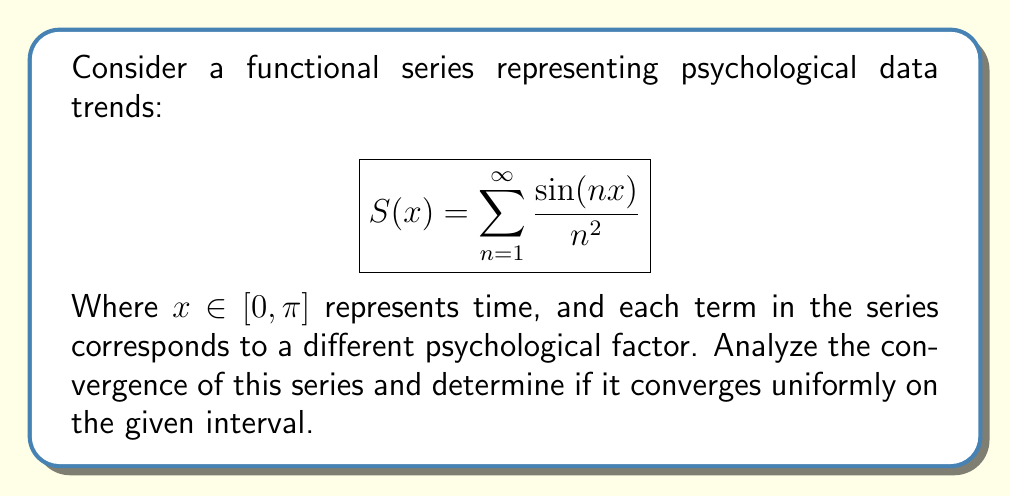Can you answer this question? To analyze the convergence of this functional series, we'll follow these steps:

1. Pointwise convergence:
First, we need to check if the series converges pointwise for all $x \in [0, \pi]$. We can use the Weierstrass M-test for this.

Let $M_n = \frac{1}{n^2}$. We know that $|\sin(nx)| \leq 1$ for all $x$ and $n$. Therefore:

$$\left|\frac{\sin(nx)}{n^2}\right| \leq \frac{1}{n^2} = M_n$$

The series $\sum_{n=1}^{\infty} M_n = \sum_{n=1}^{\infty} \frac{1}{n^2}$ is the p-series with $p=2$, which converges (it's actually $\frac{\pi^2}{6}$).

By the Weierstrass M-test, since $\sum_{n=1}^{\infty} M_n$ converges, our original series converges absolutely and uniformly on $[0, \pi]$.

2. Uniform convergence:
We've already shown uniform convergence using the Weierstrass M-test. However, we can also demonstrate it using the Cauchy criterion for uniform convergence.

For any $\epsilon > 0$, we need to find an $N$ such that for all $m > n \geq N$ and all $x \in [0, \pi]$:

$$\left|\sum_{k=n+1}^m \frac{\sin(kx)}{k^2}\right| < \epsilon$$

We can bound this sum:

$$\left|\sum_{k=n+1}^m \frac{\sin(kx)}{k^2}\right| \leq \sum_{k=n+1}^m \frac{1}{k^2} < \sum_{k=n+1}^{\infty} \frac{1}{k^2}$$

The tail of the p-series $\sum_{k=n+1}^{\infty} \frac{1}{k^2}$ can be made arbitrarily small by choosing a large enough $n$, independent of $x$. This confirms uniform convergence.

3. Continuity and differentiability:
Since the series converges uniformly and each term $\frac{\sin(nx)}{n^2}$ is continuous on $[0, \pi]$, the sum function $S(x)$ is also continuous on $[0, \pi]$.

Moreover, we can differentiate term by term:

$$S'(x) = \sum_{n=1}^{\infty} \frac{\cos(nx)}{n}$$

This new series also converges uniformly on $[0, \pi]$ (can be shown similarly), so $S(x)$ is differentiable on $(0, \pi)$.
Answer: The functional series $S(x) = \sum_{n=1}^{\infty} \frac{\sin(nx)}{n^2}$ converges uniformly on the interval $[0, \pi]$. The resulting function $S(x)$ is continuous on $[0, \pi]$ and differentiable on $(0, \pi)$. 